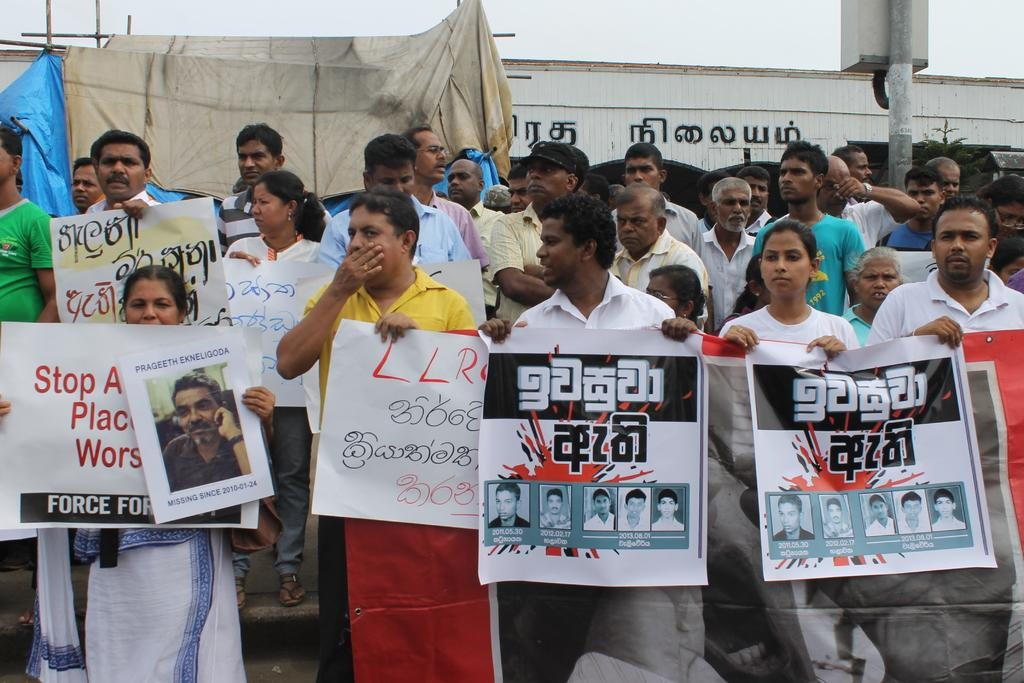How many people are in the group visible in the image? There is a group of people in the image, but the exact number cannot be determined from the provided facts. What are some people in the group holding? Some people in the group are holding banners. What can be seen in the background of the image? In the background of the image, there is a pole, a box, wooden sticks, cloth, a blue sheet, a wall, a tree, and the sky. What is the color of the sheet in the background of the image? The sheet in the background of the image is blue. What type of structure is visible in the background of the image? There is a wall in the background of the image. How many eyes can be seen on the print in the image? There is no print or eyes mentioned in the provided facts, so this question cannot be answered. 